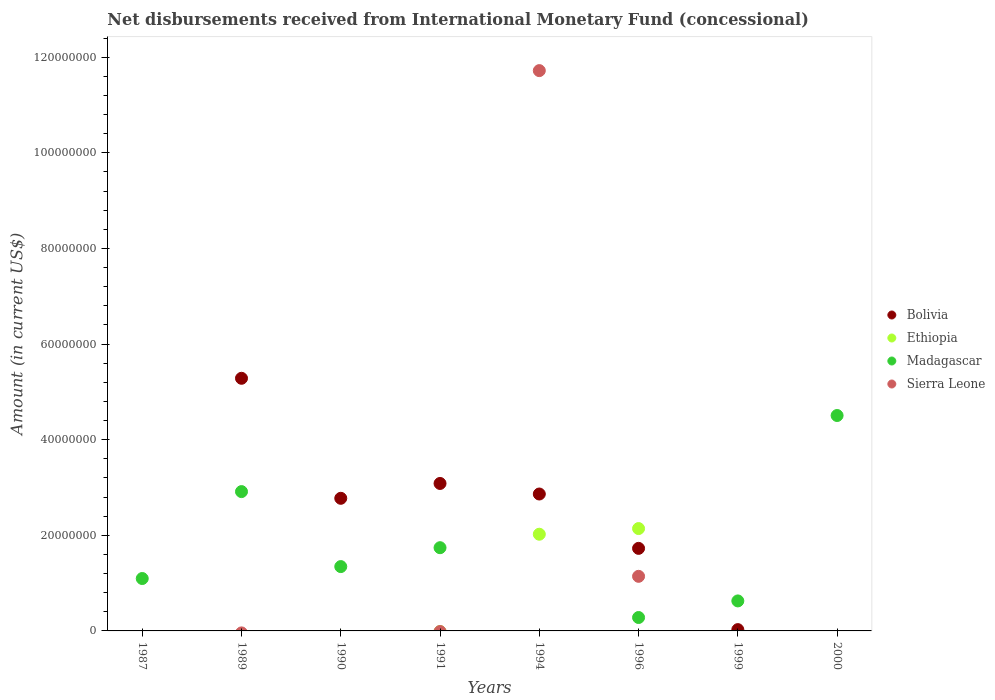How many different coloured dotlines are there?
Provide a short and direct response. 4. What is the amount of disbursements received from International Monetary Fund in Ethiopia in 1996?
Offer a very short reply. 2.14e+07. Across all years, what is the maximum amount of disbursements received from International Monetary Fund in Bolivia?
Offer a terse response. 5.28e+07. In which year was the amount of disbursements received from International Monetary Fund in Bolivia maximum?
Keep it short and to the point. 1989. What is the total amount of disbursements received from International Monetary Fund in Sierra Leone in the graph?
Your answer should be very brief. 1.29e+08. What is the difference between the amount of disbursements received from International Monetary Fund in Bolivia in 1991 and that in 1999?
Offer a terse response. 3.06e+07. What is the difference between the amount of disbursements received from International Monetary Fund in Madagascar in 1991 and the amount of disbursements received from International Monetary Fund in Bolivia in 1994?
Offer a very short reply. -1.12e+07. What is the average amount of disbursements received from International Monetary Fund in Ethiopia per year?
Give a very brief answer. 5.20e+06. In the year 1991, what is the difference between the amount of disbursements received from International Monetary Fund in Bolivia and amount of disbursements received from International Monetary Fund in Madagascar?
Provide a short and direct response. 1.34e+07. What is the ratio of the amount of disbursements received from International Monetary Fund in Madagascar in 1987 to that in 2000?
Give a very brief answer. 0.24. Is the amount of disbursements received from International Monetary Fund in Madagascar in 1990 less than that in 1999?
Offer a very short reply. No. Is the difference between the amount of disbursements received from International Monetary Fund in Bolivia in 1990 and 1996 greater than the difference between the amount of disbursements received from International Monetary Fund in Madagascar in 1990 and 1996?
Ensure brevity in your answer.  No. What is the difference between the highest and the second highest amount of disbursements received from International Monetary Fund in Madagascar?
Ensure brevity in your answer.  1.59e+07. What is the difference between the highest and the lowest amount of disbursements received from International Monetary Fund in Bolivia?
Offer a terse response. 5.28e+07. Is the sum of the amount of disbursements received from International Monetary Fund in Bolivia in 1994 and 1999 greater than the maximum amount of disbursements received from International Monetary Fund in Ethiopia across all years?
Give a very brief answer. Yes. Is it the case that in every year, the sum of the amount of disbursements received from International Monetary Fund in Ethiopia and amount of disbursements received from International Monetary Fund in Sierra Leone  is greater than the amount of disbursements received from International Monetary Fund in Madagascar?
Give a very brief answer. No. How many dotlines are there?
Provide a succinct answer. 4. What is the difference between two consecutive major ticks on the Y-axis?
Keep it short and to the point. 2.00e+07. Are the values on the major ticks of Y-axis written in scientific E-notation?
Give a very brief answer. No. Does the graph contain grids?
Your response must be concise. No. Where does the legend appear in the graph?
Ensure brevity in your answer.  Center right. How many legend labels are there?
Keep it short and to the point. 4. What is the title of the graph?
Offer a very short reply. Net disbursements received from International Monetary Fund (concessional). Does "Bahamas" appear as one of the legend labels in the graph?
Ensure brevity in your answer.  No. What is the Amount (in current US$) in Madagascar in 1987?
Provide a succinct answer. 1.10e+07. What is the Amount (in current US$) of Bolivia in 1989?
Your answer should be compact. 5.28e+07. What is the Amount (in current US$) in Ethiopia in 1989?
Keep it short and to the point. 0. What is the Amount (in current US$) of Madagascar in 1989?
Provide a short and direct response. 2.91e+07. What is the Amount (in current US$) of Bolivia in 1990?
Make the answer very short. 2.77e+07. What is the Amount (in current US$) of Madagascar in 1990?
Give a very brief answer. 1.35e+07. What is the Amount (in current US$) of Bolivia in 1991?
Keep it short and to the point. 3.08e+07. What is the Amount (in current US$) of Madagascar in 1991?
Offer a very short reply. 1.74e+07. What is the Amount (in current US$) in Sierra Leone in 1991?
Offer a very short reply. 0. What is the Amount (in current US$) of Bolivia in 1994?
Make the answer very short. 2.86e+07. What is the Amount (in current US$) in Ethiopia in 1994?
Give a very brief answer. 2.02e+07. What is the Amount (in current US$) of Sierra Leone in 1994?
Make the answer very short. 1.17e+08. What is the Amount (in current US$) of Bolivia in 1996?
Your response must be concise. 1.73e+07. What is the Amount (in current US$) in Ethiopia in 1996?
Offer a terse response. 2.14e+07. What is the Amount (in current US$) in Madagascar in 1996?
Your answer should be very brief. 2.80e+06. What is the Amount (in current US$) of Sierra Leone in 1996?
Offer a terse response. 1.14e+07. What is the Amount (in current US$) of Bolivia in 1999?
Make the answer very short. 2.72e+05. What is the Amount (in current US$) of Ethiopia in 1999?
Give a very brief answer. 0. What is the Amount (in current US$) in Madagascar in 1999?
Provide a succinct answer. 6.27e+06. What is the Amount (in current US$) of Ethiopia in 2000?
Make the answer very short. 0. What is the Amount (in current US$) in Madagascar in 2000?
Make the answer very short. 4.50e+07. What is the Amount (in current US$) in Sierra Leone in 2000?
Your answer should be very brief. 0. Across all years, what is the maximum Amount (in current US$) in Bolivia?
Make the answer very short. 5.28e+07. Across all years, what is the maximum Amount (in current US$) in Ethiopia?
Your response must be concise. 2.14e+07. Across all years, what is the maximum Amount (in current US$) in Madagascar?
Your answer should be very brief. 4.50e+07. Across all years, what is the maximum Amount (in current US$) of Sierra Leone?
Provide a short and direct response. 1.17e+08. Across all years, what is the minimum Amount (in current US$) in Bolivia?
Provide a succinct answer. 0. What is the total Amount (in current US$) in Bolivia in the graph?
Your answer should be very brief. 1.58e+08. What is the total Amount (in current US$) in Ethiopia in the graph?
Offer a terse response. 4.16e+07. What is the total Amount (in current US$) in Madagascar in the graph?
Ensure brevity in your answer.  1.25e+08. What is the total Amount (in current US$) in Sierra Leone in the graph?
Keep it short and to the point. 1.29e+08. What is the difference between the Amount (in current US$) of Madagascar in 1987 and that in 1989?
Give a very brief answer. -1.82e+07. What is the difference between the Amount (in current US$) in Madagascar in 1987 and that in 1990?
Ensure brevity in your answer.  -2.50e+06. What is the difference between the Amount (in current US$) in Madagascar in 1987 and that in 1991?
Keep it short and to the point. -6.45e+06. What is the difference between the Amount (in current US$) of Madagascar in 1987 and that in 1996?
Provide a short and direct response. 8.15e+06. What is the difference between the Amount (in current US$) of Madagascar in 1987 and that in 1999?
Keep it short and to the point. 4.68e+06. What is the difference between the Amount (in current US$) in Madagascar in 1987 and that in 2000?
Your answer should be compact. -3.41e+07. What is the difference between the Amount (in current US$) of Bolivia in 1989 and that in 1990?
Make the answer very short. 2.51e+07. What is the difference between the Amount (in current US$) in Madagascar in 1989 and that in 1990?
Offer a terse response. 1.57e+07. What is the difference between the Amount (in current US$) of Bolivia in 1989 and that in 1991?
Give a very brief answer. 2.20e+07. What is the difference between the Amount (in current US$) of Madagascar in 1989 and that in 1991?
Your answer should be compact. 1.17e+07. What is the difference between the Amount (in current US$) in Bolivia in 1989 and that in 1994?
Provide a short and direct response. 2.42e+07. What is the difference between the Amount (in current US$) of Bolivia in 1989 and that in 1996?
Your answer should be compact. 3.56e+07. What is the difference between the Amount (in current US$) in Madagascar in 1989 and that in 1996?
Offer a terse response. 2.63e+07. What is the difference between the Amount (in current US$) in Bolivia in 1989 and that in 1999?
Keep it short and to the point. 5.26e+07. What is the difference between the Amount (in current US$) of Madagascar in 1989 and that in 1999?
Provide a short and direct response. 2.29e+07. What is the difference between the Amount (in current US$) in Madagascar in 1989 and that in 2000?
Keep it short and to the point. -1.59e+07. What is the difference between the Amount (in current US$) in Bolivia in 1990 and that in 1991?
Your answer should be compact. -3.10e+06. What is the difference between the Amount (in current US$) of Madagascar in 1990 and that in 1991?
Your response must be concise. -3.95e+06. What is the difference between the Amount (in current US$) in Bolivia in 1990 and that in 1994?
Your response must be concise. -8.97e+05. What is the difference between the Amount (in current US$) in Bolivia in 1990 and that in 1996?
Provide a succinct answer. 1.05e+07. What is the difference between the Amount (in current US$) in Madagascar in 1990 and that in 1996?
Ensure brevity in your answer.  1.06e+07. What is the difference between the Amount (in current US$) in Bolivia in 1990 and that in 1999?
Provide a succinct answer. 2.75e+07. What is the difference between the Amount (in current US$) in Madagascar in 1990 and that in 1999?
Keep it short and to the point. 7.18e+06. What is the difference between the Amount (in current US$) of Madagascar in 1990 and that in 2000?
Offer a terse response. -3.16e+07. What is the difference between the Amount (in current US$) in Bolivia in 1991 and that in 1994?
Offer a very short reply. 2.21e+06. What is the difference between the Amount (in current US$) of Bolivia in 1991 and that in 1996?
Make the answer very short. 1.36e+07. What is the difference between the Amount (in current US$) of Madagascar in 1991 and that in 1996?
Ensure brevity in your answer.  1.46e+07. What is the difference between the Amount (in current US$) in Bolivia in 1991 and that in 1999?
Your response must be concise. 3.06e+07. What is the difference between the Amount (in current US$) in Madagascar in 1991 and that in 1999?
Keep it short and to the point. 1.11e+07. What is the difference between the Amount (in current US$) of Madagascar in 1991 and that in 2000?
Your answer should be compact. -2.76e+07. What is the difference between the Amount (in current US$) in Bolivia in 1994 and that in 1996?
Make the answer very short. 1.14e+07. What is the difference between the Amount (in current US$) of Ethiopia in 1994 and that in 1996?
Provide a short and direct response. -1.19e+06. What is the difference between the Amount (in current US$) of Sierra Leone in 1994 and that in 1996?
Keep it short and to the point. 1.06e+08. What is the difference between the Amount (in current US$) in Bolivia in 1994 and that in 1999?
Your answer should be very brief. 2.84e+07. What is the difference between the Amount (in current US$) in Bolivia in 1996 and that in 1999?
Provide a succinct answer. 1.70e+07. What is the difference between the Amount (in current US$) in Madagascar in 1996 and that in 1999?
Give a very brief answer. -3.47e+06. What is the difference between the Amount (in current US$) of Madagascar in 1996 and that in 2000?
Your answer should be very brief. -4.22e+07. What is the difference between the Amount (in current US$) in Madagascar in 1999 and that in 2000?
Offer a terse response. -3.88e+07. What is the difference between the Amount (in current US$) in Madagascar in 1987 and the Amount (in current US$) in Sierra Leone in 1994?
Ensure brevity in your answer.  -1.06e+08. What is the difference between the Amount (in current US$) of Madagascar in 1987 and the Amount (in current US$) of Sierra Leone in 1996?
Give a very brief answer. -4.59e+05. What is the difference between the Amount (in current US$) of Bolivia in 1989 and the Amount (in current US$) of Madagascar in 1990?
Offer a terse response. 3.94e+07. What is the difference between the Amount (in current US$) of Bolivia in 1989 and the Amount (in current US$) of Madagascar in 1991?
Ensure brevity in your answer.  3.54e+07. What is the difference between the Amount (in current US$) in Bolivia in 1989 and the Amount (in current US$) in Ethiopia in 1994?
Your answer should be very brief. 3.26e+07. What is the difference between the Amount (in current US$) of Bolivia in 1989 and the Amount (in current US$) of Sierra Leone in 1994?
Provide a short and direct response. -6.43e+07. What is the difference between the Amount (in current US$) of Madagascar in 1989 and the Amount (in current US$) of Sierra Leone in 1994?
Ensure brevity in your answer.  -8.80e+07. What is the difference between the Amount (in current US$) of Bolivia in 1989 and the Amount (in current US$) of Ethiopia in 1996?
Give a very brief answer. 3.14e+07. What is the difference between the Amount (in current US$) of Bolivia in 1989 and the Amount (in current US$) of Madagascar in 1996?
Offer a terse response. 5.00e+07. What is the difference between the Amount (in current US$) in Bolivia in 1989 and the Amount (in current US$) in Sierra Leone in 1996?
Ensure brevity in your answer.  4.14e+07. What is the difference between the Amount (in current US$) in Madagascar in 1989 and the Amount (in current US$) in Sierra Leone in 1996?
Give a very brief answer. 1.77e+07. What is the difference between the Amount (in current US$) of Bolivia in 1989 and the Amount (in current US$) of Madagascar in 1999?
Offer a very short reply. 4.66e+07. What is the difference between the Amount (in current US$) in Bolivia in 1989 and the Amount (in current US$) in Madagascar in 2000?
Offer a very short reply. 7.78e+06. What is the difference between the Amount (in current US$) of Bolivia in 1990 and the Amount (in current US$) of Madagascar in 1991?
Ensure brevity in your answer.  1.03e+07. What is the difference between the Amount (in current US$) of Bolivia in 1990 and the Amount (in current US$) of Ethiopia in 1994?
Ensure brevity in your answer.  7.52e+06. What is the difference between the Amount (in current US$) in Bolivia in 1990 and the Amount (in current US$) in Sierra Leone in 1994?
Provide a succinct answer. -8.94e+07. What is the difference between the Amount (in current US$) in Madagascar in 1990 and the Amount (in current US$) in Sierra Leone in 1994?
Your response must be concise. -1.04e+08. What is the difference between the Amount (in current US$) of Bolivia in 1990 and the Amount (in current US$) of Ethiopia in 1996?
Ensure brevity in your answer.  6.33e+06. What is the difference between the Amount (in current US$) in Bolivia in 1990 and the Amount (in current US$) in Madagascar in 1996?
Provide a short and direct response. 2.49e+07. What is the difference between the Amount (in current US$) in Bolivia in 1990 and the Amount (in current US$) in Sierra Leone in 1996?
Make the answer very short. 1.63e+07. What is the difference between the Amount (in current US$) in Madagascar in 1990 and the Amount (in current US$) in Sierra Leone in 1996?
Ensure brevity in your answer.  2.04e+06. What is the difference between the Amount (in current US$) of Bolivia in 1990 and the Amount (in current US$) of Madagascar in 1999?
Keep it short and to the point. 2.15e+07. What is the difference between the Amount (in current US$) in Bolivia in 1990 and the Amount (in current US$) in Madagascar in 2000?
Your answer should be compact. -1.73e+07. What is the difference between the Amount (in current US$) in Bolivia in 1991 and the Amount (in current US$) in Ethiopia in 1994?
Your response must be concise. 1.06e+07. What is the difference between the Amount (in current US$) in Bolivia in 1991 and the Amount (in current US$) in Sierra Leone in 1994?
Offer a terse response. -8.63e+07. What is the difference between the Amount (in current US$) of Madagascar in 1991 and the Amount (in current US$) of Sierra Leone in 1994?
Ensure brevity in your answer.  -9.98e+07. What is the difference between the Amount (in current US$) in Bolivia in 1991 and the Amount (in current US$) in Ethiopia in 1996?
Your response must be concise. 9.43e+06. What is the difference between the Amount (in current US$) in Bolivia in 1991 and the Amount (in current US$) in Madagascar in 1996?
Offer a terse response. 2.80e+07. What is the difference between the Amount (in current US$) of Bolivia in 1991 and the Amount (in current US$) of Sierra Leone in 1996?
Keep it short and to the point. 1.94e+07. What is the difference between the Amount (in current US$) of Madagascar in 1991 and the Amount (in current US$) of Sierra Leone in 1996?
Keep it short and to the point. 5.99e+06. What is the difference between the Amount (in current US$) of Bolivia in 1991 and the Amount (in current US$) of Madagascar in 1999?
Ensure brevity in your answer.  2.46e+07. What is the difference between the Amount (in current US$) of Bolivia in 1991 and the Amount (in current US$) of Madagascar in 2000?
Offer a very short reply. -1.42e+07. What is the difference between the Amount (in current US$) of Bolivia in 1994 and the Amount (in current US$) of Ethiopia in 1996?
Keep it short and to the point. 7.23e+06. What is the difference between the Amount (in current US$) of Bolivia in 1994 and the Amount (in current US$) of Madagascar in 1996?
Your response must be concise. 2.58e+07. What is the difference between the Amount (in current US$) in Bolivia in 1994 and the Amount (in current US$) in Sierra Leone in 1996?
Give a very brief answer. 1.72e+07. What is the difference between the Amount (in current US$) in Ethiopia in 1994 and the Amount (in current US$) in Madagascar in 1996?
Your answer should be compact. 1.74e+07. What is the difference between the Amount (in current US$) of Ethiopia in 1994 and the Amount (in current US$) of Sierra Leone in 1996?
Ensure brevity in your answer.  8.80e+06. What is the difference between the Amount (in current US$) in Bolivia in 1994 and the Amount (in current US$) in Madagascar in 1999?
Ensure brevity in your answer.  2.24e+07. What is the difference between the Amount (in current US$) of Ethiopia in 1994 and the Amount (in current US$) of Madagascar in 1999?
Make the answer very short. 1.39e+07. What is the difference between the Amount (in current US$) in Bolivia in 1994 and the Amount (in current US$) in Madagascar in 2000?
Give a very brief answer. -1.64e+07. What is the difference between the Amount (in current US$) in Ethiopia in 1994 and the Amount (in current US$) in Madagascar in 2000?
Your answer should be very brief. -2.48e+07. What is the difference between the Amount (in current US$) in Bolivia in 1996 and the Amount (in current US$) in Madagascar in 1999?
Make the answer very short. 1.10e+07. What is the difference between the Amount (in current US$) of Ethiopia in 1996 and the Amount (in current US$) of Madagascar in 1999?
Give a very brief answer. 1.51e+07. What is the difference between the Amount (in current US$) of Bolivia in 1996 and the Amount (in current US$) of Madagascar in 2000?
Provide a succinct answer. -2.78e+07. What is the difference between the Amount (in current US$) in Ethiopia in 1996 and the Amount (in current US$) in Madagascar in 2000?
Provide a succinct answer. -2.36e+07. What is the difference between the Amount (in current US$) of Bolivia in 1999 and the Amount (in current US$) of Madagascar in 2000?
Your response must be concise. -4.48e+07. What is the average Amount (in current US$) of Bolivia per year?
Give a very brief answer. 1.97e+07. What is the average Amount (in current US$) of Ethiopia per year?
Give a very brief answer. 5.20e+06. What is the average Amount (in current US$) of Madagascar per year?
Give a very brief answer. 1.56e+07. What is the average Amount (in current US$) in Sierra Leone per year?
Your answer should be compact. 1.61e+07. In the year 1989, what is the difference between the Amount (in current US$) in Bolivia and Amount (in current US$) in Madagascar?
Provide a succinct answer. 2.37e+07. In the year 1990, what is the difference between the Amount (in current US$) in Bolivia and Amount (in current US$) in Madagascar?
Your answer should be very brief. 1.43e+07. In the year 1991, what is the difference between the Amount (in current US$) in Bolivia and Amount (in current US$) in Madagascar?
Ensure brevity in your answer.  1.34e+07. In the year 1994, what is the difference between the Amount (in current US$) in Bolivia and Amount (in current US$) in Ethiopia?
Your answer should be very brief. 8.41e+06. In the year 1994, what is the difference between the Amount (in current US$) in Bolivia and Amount (in current US$) in Sierra Leone?
Provide a short and direct response. -8.85e+07. In the year 1994, what is the difference between the Amount (in current US$) in Ethiopia and Amount (in current US$) in Sierra Leone?
Make the answer very short. -9.70e+07. In the year 1996, what is the difference between the Amount (in current US$) of Bolivia and Amount (in current US$) of Ethiopia?
Offer a terse response. -4.14e+06. In the year 1996, what is the difference between the Amount (in current US$) in Bolivia and Amount (in current US$) in Madagascar?
Offer a very short reply. 1.45e+07. In the year 1996, what is the difference between the Amount (in current US$) in Bolivia and Amount (in current US$) in Sierra Leone?
Provide a succinct answer. 5.85e+06. In the year 1996, what is the difference between the Amount (in current US$) of Ethiopia and Amount (in current US$) of Madagascar?
Make the answer very short. 1.86e+07. In the year 1996, what is the difference between the Amount (in current US$) in Ethiopia and Amount (in current US$) in Sierra Leone?
Offer a terse response. 9.99e+06. In the year 1996, what is the difference between the Amount (in current US$) of Madagascar and Amount (in current US$) of Sierra Leone?
Offer a terse response. -8.61e+06. In the year 1999, what is the difference between the Amount (in current US$) of Bolivia and Amount (in current US$) of Madagascar?
Ensure brevity in your answer.  -6.00e+06. What is the ratio of the Amount (in current US$) in Madagascar in 1987 to that in 1989?
Give a very brief answer. 0.38. What is the ratio of the Amount (in current US$) in Madagascar in 1987 to that in 1990?
Your response must be concise. 0.81. What is the ratio of the Amount (in current US$) in Madagascar in 1987 to that in 1991?
Provide a short and direct response. 0.63. What is the ratio of the Amount (in current US$) of Madagascar in 1987 to that in 1996?
Ensure brevity in your answer.  3.91. What is the ratio of the Amount (in current US$) of Madagascar in 1987 to that in 1999?
Give a very brief answer. 1.75. What is the ratio of the Amount (in current US$) of Madagascar in 1987 to that in 2000?
Give a very brief answer. 0.24. What is the ratio of the Amount (in current US$) in Bolivia in 1989 to that in 1990?
Your response must be concise. 1.9. What is the ratio of the Amount (in current US$) of Madagascar in 1989 to that in 1990?
Keep it short and to the point. 2.17. What is the ratio of the Amount (in current US$) of Bolivia in 1989 to that in 1991?
Give a very brief answer. 1.71. What is the ratio of the Amount (in current US$) of Madagascar in 1989 to that in 1991?
Make the answer very short. 1.67. What is the ratio of the Amount (in current US$) in Bolivia in 1989 to that in 1994?
Keep it short and to the point. 1.85. What is the ratio of the Amount (in current US$) in Bolivia in 1989 to that in 1996?
Your response must be concise. 3.06. What is the ratio of the Amount (in current US$) of Madagascar in 1989 to that in 1996?
Give a very brief answer. 10.39. What is the ratio of the Amount (in current US$) of Bolivia in 1989 to that in 1999?
Provide a short and direct response. 194.24. What is the ratio of the Amount (in current US$) of Madagascar in 1989 to that in 1999?
Your answer should be very brief. 4.64. What is the ratio of the Amount (in current US$) in Madagascar in 1989 to that in 2000?
Offer a very short reply. 0.65. What is the ratio of the Amount (in current US$) in Bolivia in 1990 to that in 1991?
Provide a succinct answer. 0.9. What is the ratio of the Amount (in current US$) in Madagascar in 1990 to that in 1991?
Offer a terse response. 0.77. What is the ratio of the Amount (in current US$) of Bolivia in 1990 to that in 1994?
Your answer should be compact. 0.97. What is the ratio of the Amount (in current US$) in Bolivia in 1990 to that in 1996?
Provide a short and direct response. 1.61. What is the ratio of the Amount (in current US$) in Madagascar in 1990 to that in 1996?
Make the answer very short. 4.8. What is the ratio of the Amount (in current US$) of Bolivia in 1990 to that in 1999?
Offer a terse response. 101.97. What is the ratio of the Amount (in current US$) of Madagascar in 1990 to that in 1999?
Your answer should be compact. 2.14. What is the ratio of the Amount (in current US$) of Madagascar in 1990 to that in 2000?
Make the answer very short. 0.3. What is the ratio of the Amount (in current US$) of Bolivia in 1991 to that in 1994?
Give a very brief answer. 1.08. What is the ratio of the Amount (in current US$) in Bolivia in 1991 to that in 1996?
Offer a very short reply. 1.79. What is the ratio of the Amount (in current US$) in Madagascar in 1991 to that in 1996?
Ensure brevity in your answer.  6.21. What is the ratio of the Amount (in current US$) of Bolivia in 1991 to that in 1999?
Your answer should be compact. 113.38. What is the ratio of the Amount (in current US$) of Madagascar in 1991 to that in 1999?
Your answer should be compact. 2.77. What is the ratio of the Amount (in current US$) in Madagascar in 1991 to that in 2000?
Ensure brevity in your answer.  0.39. What is the ratio of the Amount (in current US$) of Bolivia in 1994 to that in 1996?
Your answer should be very brief. 1.66. What is the ratio of the Amount (in current US$) in Ethiopia in 1994 to that in 1996?
Give a very brief answer. 0.94. What is the ratio of the Amount (in current US$) in Sierra Leone in 1994 to that in 1996?
Give a very brief answer. 10.26. What is the ratio of the Amount (in current US$) in Bolivia in 1994 to that in 1999?
Provide a succinct answer. 105.27. What is the ratio of the Amount (in current US$) in Bolivia in 1996 to that in 1999?
Give a very brief answer. 63.47. What is the ratio of the Amount (in current US$) of Madagascar in 1996 to that in 1999?
Provide a short and direct response. 0.45. What is the ratio of the Amount (in current US$) in Madagascar in 1996 to that in 2000?
Your response must be concise. 0.06. What is the ratio of the Amount (in current US$) in Madagascar in 1999 to that in 2000?
Offer a terse response. 0.14. What is the difference between the highest and the second highest Amount (in current US$) in Bolivia?
Your answer should be very brief. 2.20e+07. What is the difference between the highest and the second highest Amount (in current US$) of Madagascar?
Provide a succinct answer. 1.59e+07. What is the difference between the highest and the lowest Amount (in current US$) of Bolivia?
Your response must be concise. 5.28e+07. What is the difference between the highest and the lowest Amount (in current US$) in Ethiopia?
Provide a short and direct response. 2.14e+07. What is the difference between the highest and the lowest Amount (in current US$) in Madagascar?
Make the answer very short. 4.50e+07. What is the difference between the highest and the lowest Amount (in current US$) of Sierra Leone?
Your response must be concise. 1.17e+08. 